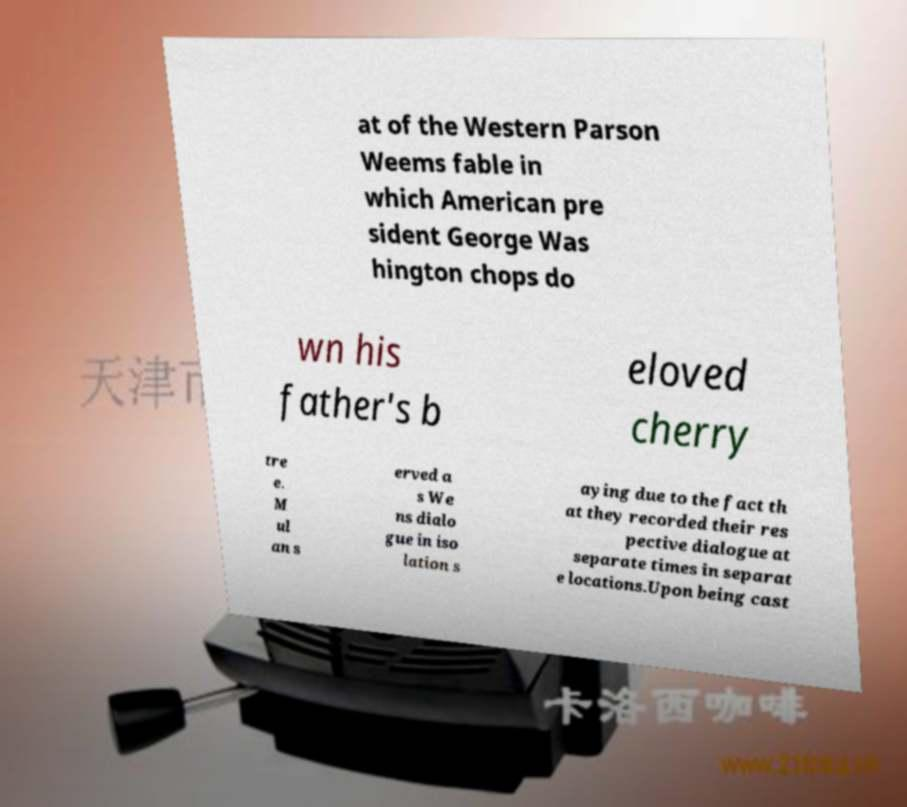Can you accurately transcribe the text from the provided image for me? at of the Western Parson Weems fable in which American pre sident George Was hington chops do wn his father's b eloved cherry tre e. M ul an s erved a s We ns dialo gue in iso lation s aying due to the fact th at they recorded their res pective dialogue at separate times in separat e locations.Upon being cast 